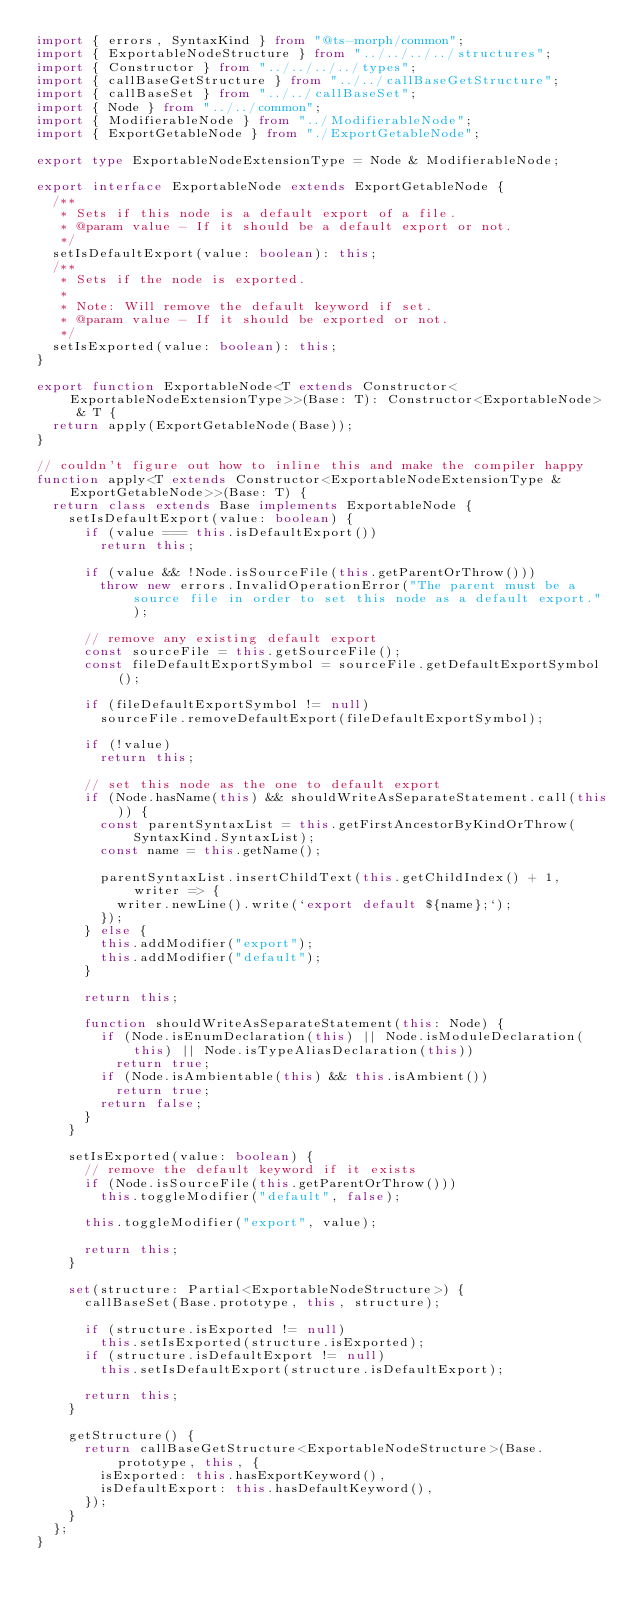<code> <loc_0><loc_0><loc_500><loc_500><_TypeScript_>import { errors, SyntaxKind } from "@ts-morph/common";
import { ExportableNodeStructure } from "../../../../structures";
import { Constructor } from "../../../../types";
import { callBaseGetStructure } from "../../callBaseGetStructure";
import { callBaseSet } from "../../callBaseSet";
import { Node } from "../../common";
import { ModifierableNode } from "../ModifierableNode";
import { ExportGetableNode } from "./ExportGetableNode";

export type ExportableNodeExtensionType = Node & ModifierableNode;

export interface ExportableNode extends ExportGetableNode {
  /**
   * Sets if this node is a default export of a file.
   * @param value - If it should be a default export or not.
   */
  setIsDefaultExport(value: boolean): this;
  /**
   * Sets if the node is exported.
   *
   * Note: Will remove the default keyword if set.
   * @param value - If it should be exported or not.
   */
  setIsExported(value: boolean): this;
}

export function ExportableNode<T extends Constructor<ExportableNodeExtensionType>>(Base: T): Constructor<ExportableNode> & T {
  return apply(ExportGetableNode(Base));
}

// couldn't figure out how to inline this and make the compiler happy
function apply<T extends Constructor<ExportableNodeExtensionType & ExportGetableNode>>(Base: T) {
  return class extends Base implements ExportableNode {
    setIsDefaultExport(value: boolean) {
      if (value === this.isDefaultExport())
        return this;

      if (value && !Node.isSourceFile(this.getParentOrThrow()))
        throw new errors.InvalidOperationError("The parent must be a source file in order to set this node as a default export.");

      // remove any existing default export
      const sourceFile = this.getSourceFile();
      const fileDefaultExportSymbol = sourceFile.getDefaultExportSymbol();

      if (fileDefaultExportSymbol != null)
        sourceFile.removeDefaultExport(fileDefaultExportSymbol);

      if (!value)
        return this;

      // set this node as the one to default export
      if (Node.hasName(this) && shouldWriteAsSeparateStatement.call(this)) {
        const parentSyntaxList = this.getFirstAncestorByKindOrThrow(SyntaxKind.SyntaxList);
        const name = this.getName();

        parentSyntaxList.insertChildText(this.getChildIndex() + 1, writer => {
          writer.newLine().write(`export default ${name};`);
        });
      } else {
        this.addModifier("export");
        this.addModifier("default");
      }

      return this;

      function shouldWriteAsSeparateStatement(this: Node) {
        if (Node.isEnumDeclaration(this) || Node.isModuleDeclaration(this) || Node.isTypeAliasDeclaration(this))
          return true;
        if (Node.isAmbientable(this) && this.isAmbient())
          return true;
        return false;
      }
    }

    setIsExported(value: boolean) {
      // remove the default keyword if it exists
      if (Node.isSourceFile(this.getParentOrThrow()))
        this.toggleModifier("default", false);

      this.toggleModifier("export", value);

      return this;
    }

    set(structure: Partial<ExportableNodeStructure>) {
      callBaseSet(Base.prototype, this, structure);

      if (structure.isExported != null)
        this.setIsExported(structure.isExported);
      if (structure.isDefaultExport != null)
        this.setIsDefaultExport(structure.isDefaultExport);

      return this;
    }

    getStructure() {
      return callBaseGetStructure<ExportableNodeStructure>(Base.prototype, this, {
        isExported: this.hasExportKeyword(),
        isDefaultExport: this.hasDefaultKeyword(),
      });
    }
  };
}
</code> 